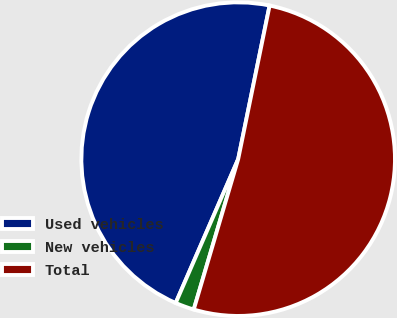Convert chart to OTSL. <chart><loc_0><loc_0><loc_500><loc_500><pie_chart><fcel>Used vehicles<fcel>New vehicles<fcel>Total<nl><fcel>46.69%<fcel>1.95%<fcel>51.36%<nl></chart> 